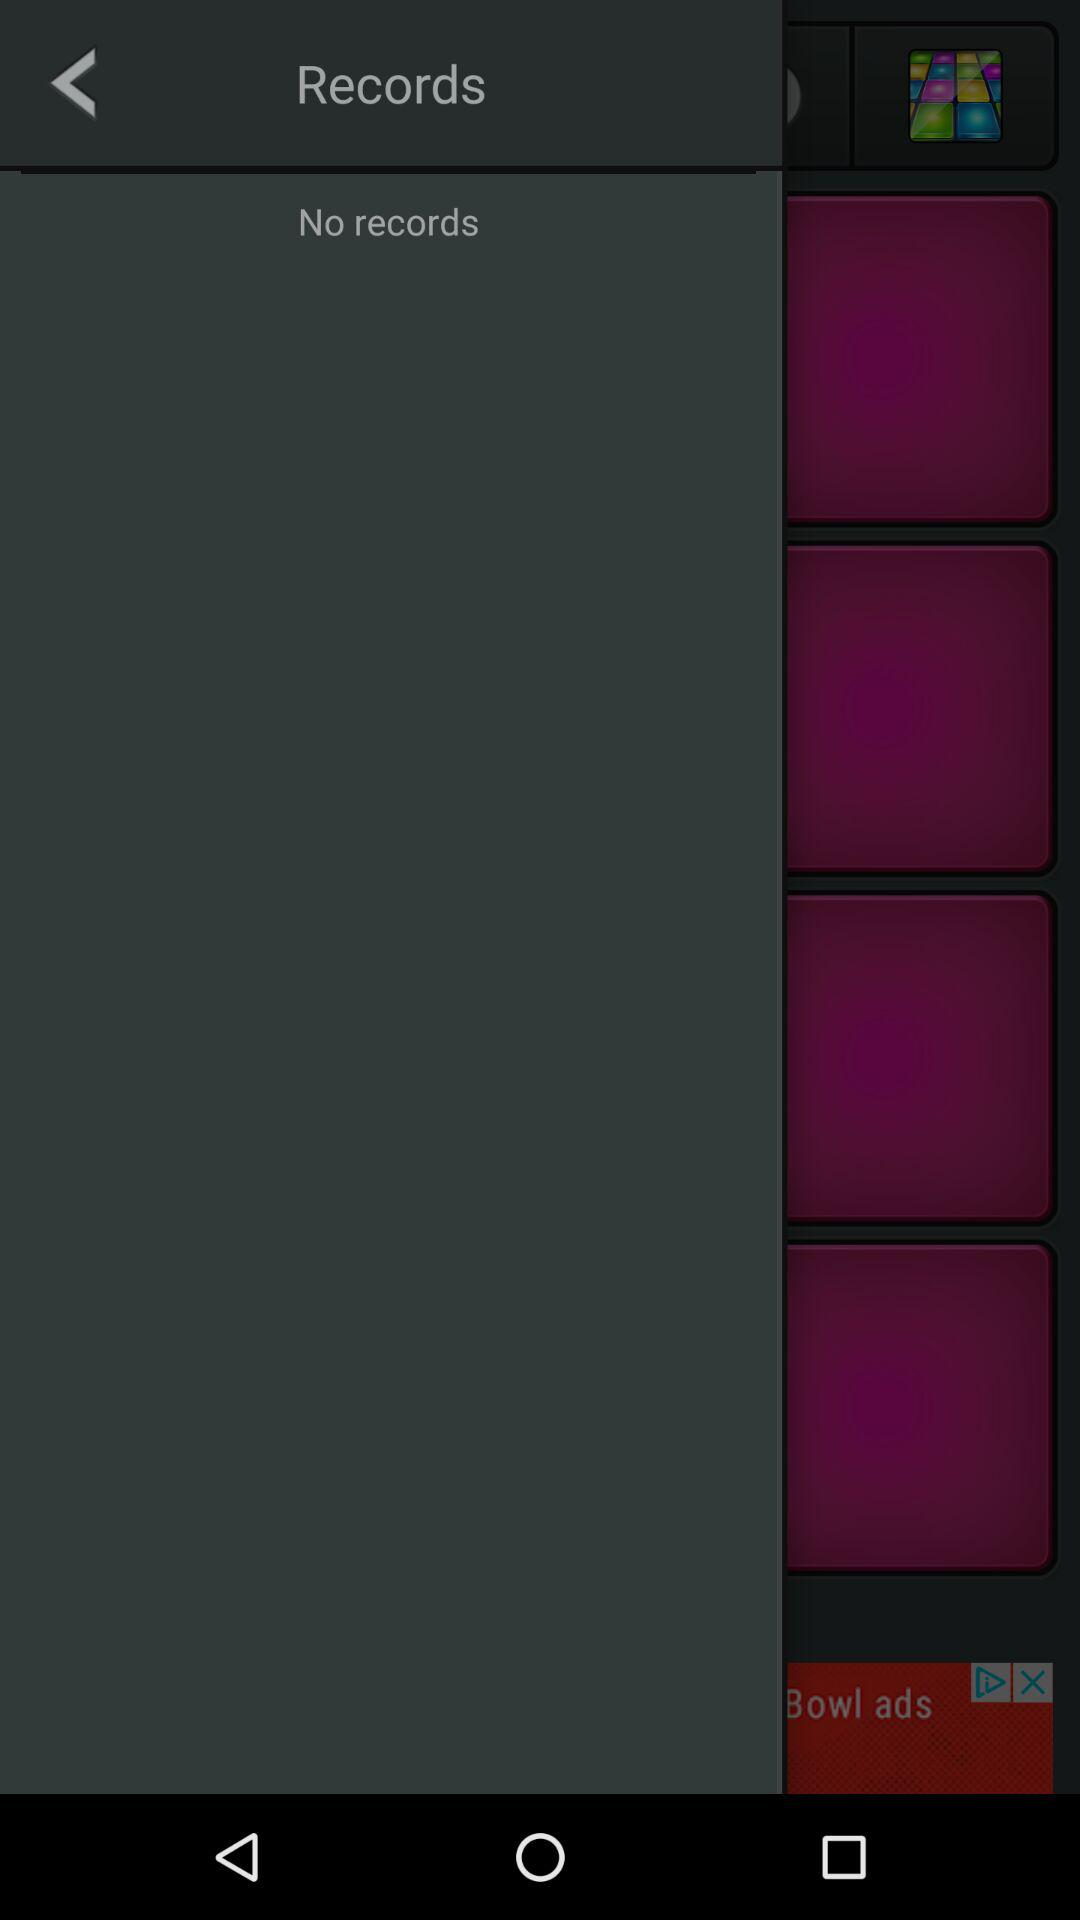How many purple squares are there?
Answer the question using a single word or phrase. 4 